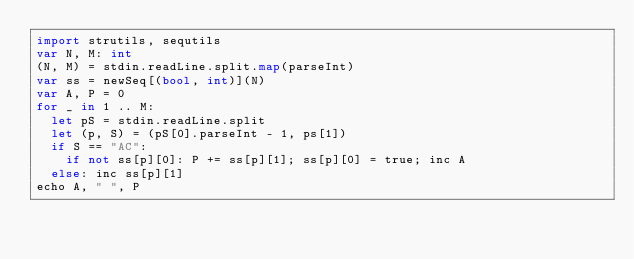Convert code to text. <code><loc_0><loc_0><loc_500><loc_500><_Nim_>import strutils, sequtils
var N, M: int
(N, M) = stdin.readLine.split.map(parseInt)
var ss = newSeq[(bool, int)](N)
var A, P = 0
for _ in 1 .. M:
  let pS = stdin.readLine.split
  let (p, S) = (pS[0].parseInt - 1, ps[1])
  if S == "AC":
    if not ss[p][0]: P += ss[p][1]; ss[p][0] = true; inc A
  else: inc ss[p][1]
echo A, " ", P</code> 